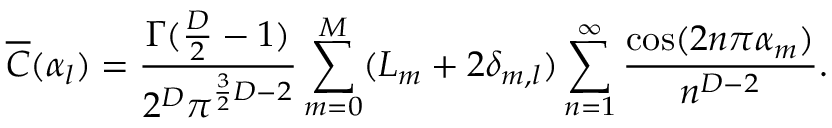Convert formula to latex. <formula><loc_0><loc_0><loc_500><loc_500>\overline { C } ( \alpha _ { l } ) = \frac { \Gamma ( \frac { D } { 2 } - 1 ) } { 2 ^ { D } \pi ^ { \frac { 3 } { 2 } D - 2 } } \sum _ { m = 0 } ^ { M } ( L _ { m } + 2 \delta _ { m , l } ) \sum _ { n = 1 } ^ { \infty } \frac { \cos ( 2 n \pi \alpha _ { m } ) } { n ^ { D - 2 } } .</formula> 